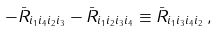<formula> <loc_0><loc_0><loc_500><loc_500>- \bar { R } _ { i _ { 1 } i _ { 4 } i _ { 2 } i _ { 3 } } - \bar { R } _ { i _ { 1 } i _ { 2 } i _ { 3 } i _ { 4 } } \equiv \bar { R } _ { i _ { 1 } i _ { 3 } i _ { 4 } i _ { 2 } } \, ,</formula> 